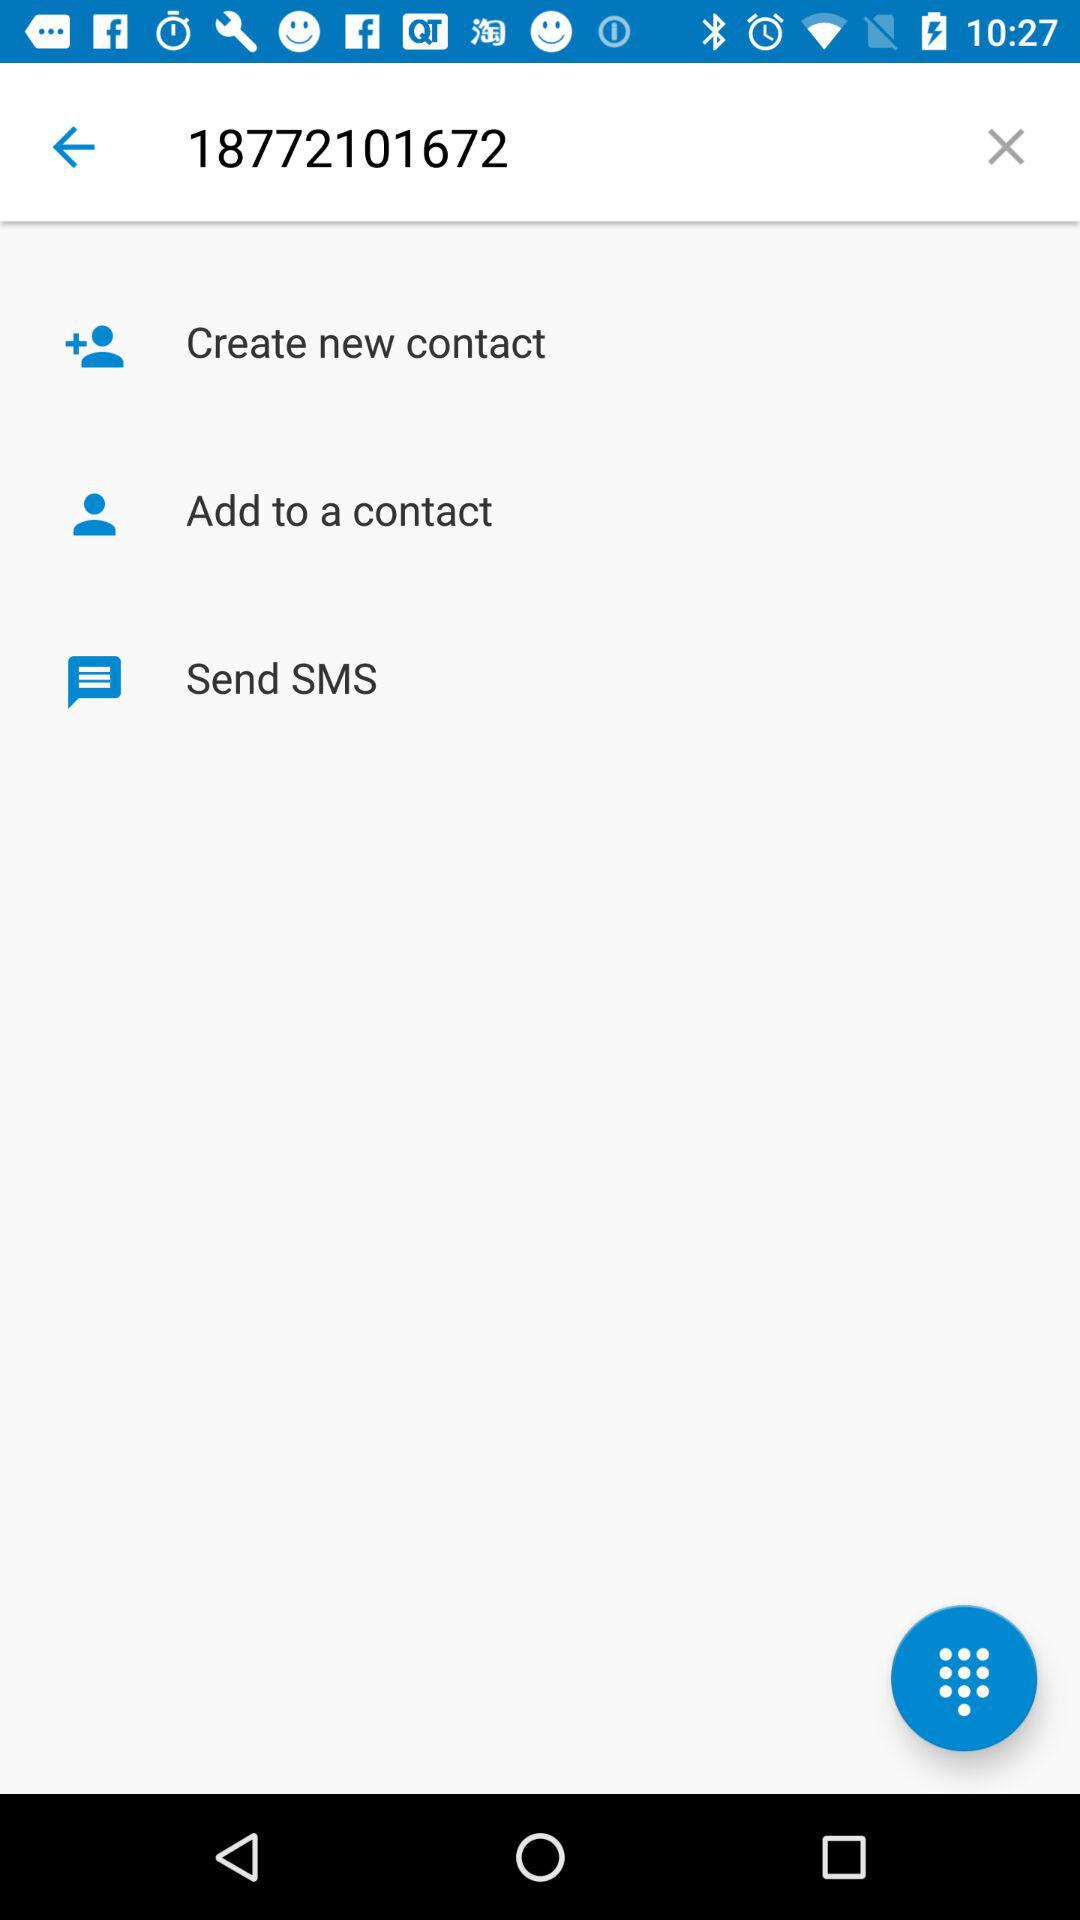What is the number in the search box? The number in the search box is 18772101672. 